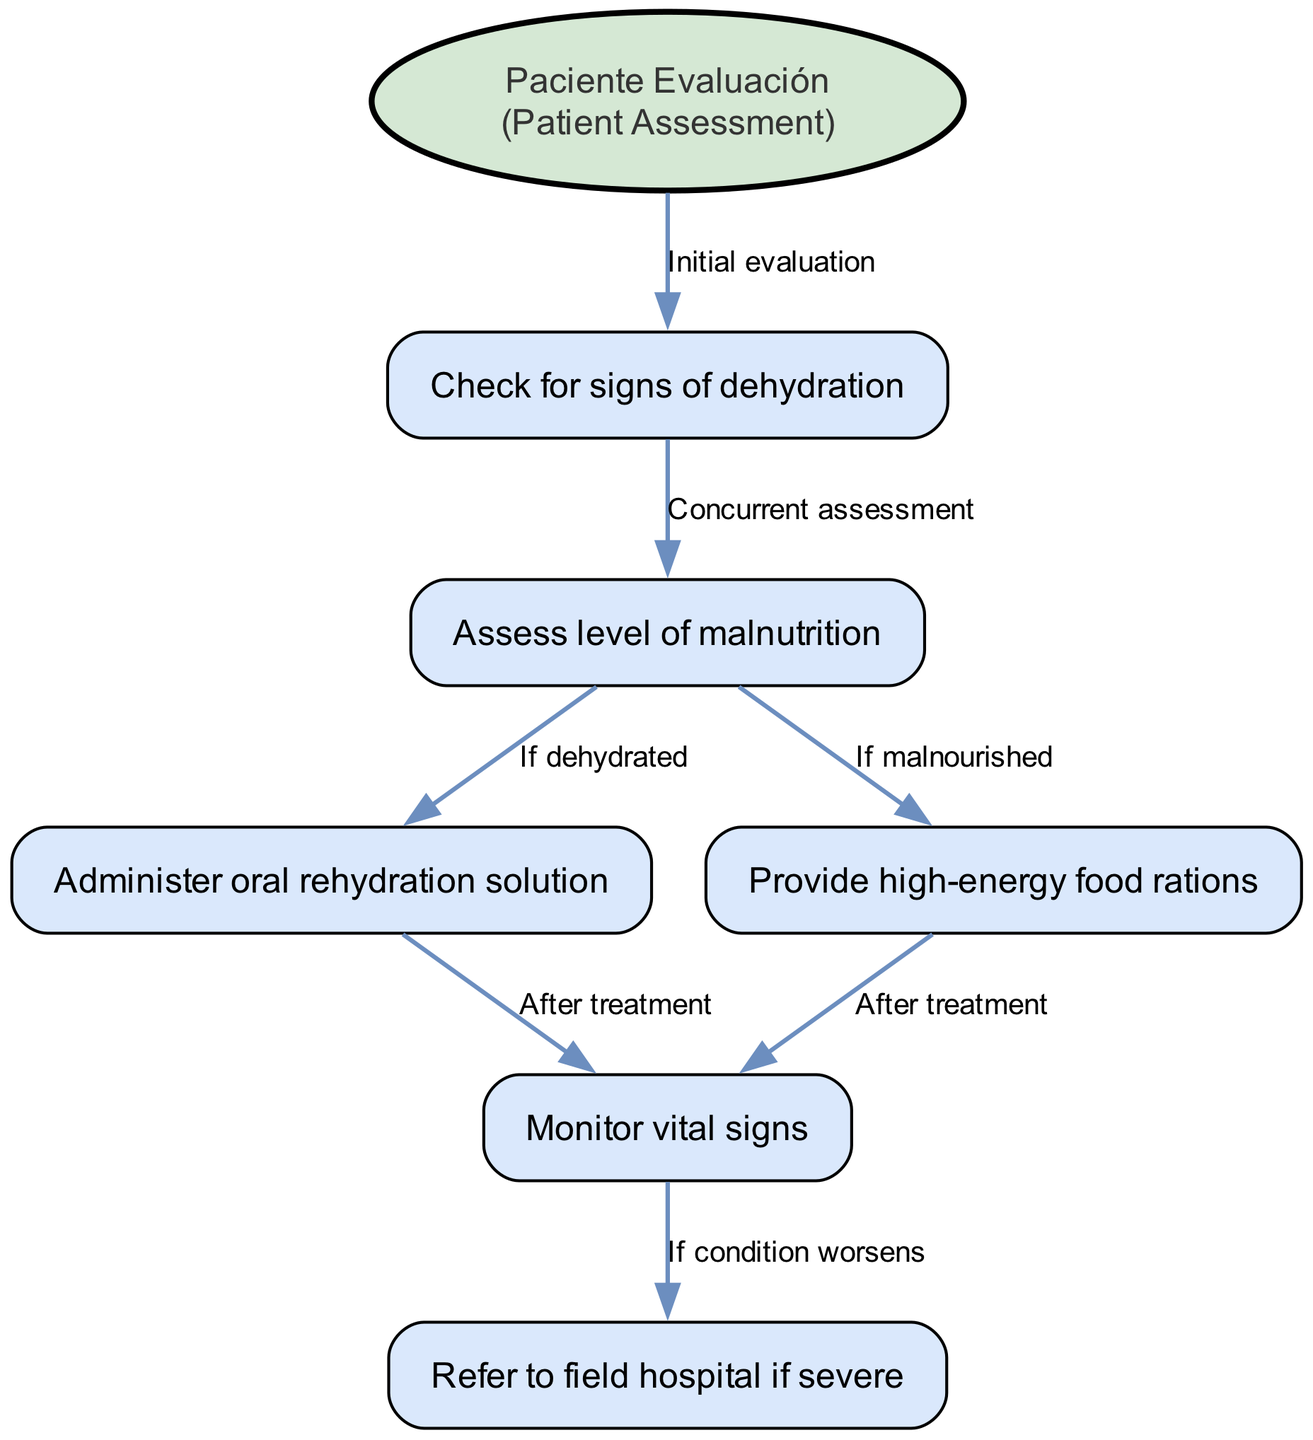What is the starting point of the clinical pathway? The starting point of the clinical pathway is labeled as "Patient assessment". It is the initial evaluation step before any other actions can be taken regarding dehydration or malnutrition.
Answer: Patient assessment How many nodes are in the diagram? To find the number of nodes, we count each unique step noted in the diagram, including the start and the various assessments or treatments. There are a total of six nodes listed in the data provided.
Answer: 6 Which node comes after "Check for signs of dehydration"? Following the node "Check for signs of dehydration", the next node represents the assessment of malnutrition. The relationship is indicated with an edge labeled "Concurrent assessment".
Answer: Assess level of malnutrition What action takes place after administering oral rehydration solution? After administering oral rehydration solution, the next action is monitoring vital signs which signifies the importance of keeping track of the patient's condition following the treatment.
Answer: Monitor vital signs What is the condition under which to provide high-energy food rations? High-energy food rations are provided when the level of malnutrition has been assessed as significant, which is indicated in the diagram as an outcome from the malnutrition assessment step.
Answer: If malnourished In what scenario would you refer a patient to the field hospital? A patient would be referred to a field hospital if their condition worsens after monitoring vital signs. This shows the need for further medical attention beyond what can be offered in the initial assessment.
Answer: If condition worsens What indicates a need for oral rehydration solution? The necessity for oral rehydration solution is indicated when the patient has been assessed and found to be dehydrated after checking for signs of dehydration.
Answer: If dehydrated How many edges are present in the diagram? Counting the edges connecting the different nodes, we find five edges that represent the various connections and flow from one step to another within the clinical pathway.
Answer: 5 